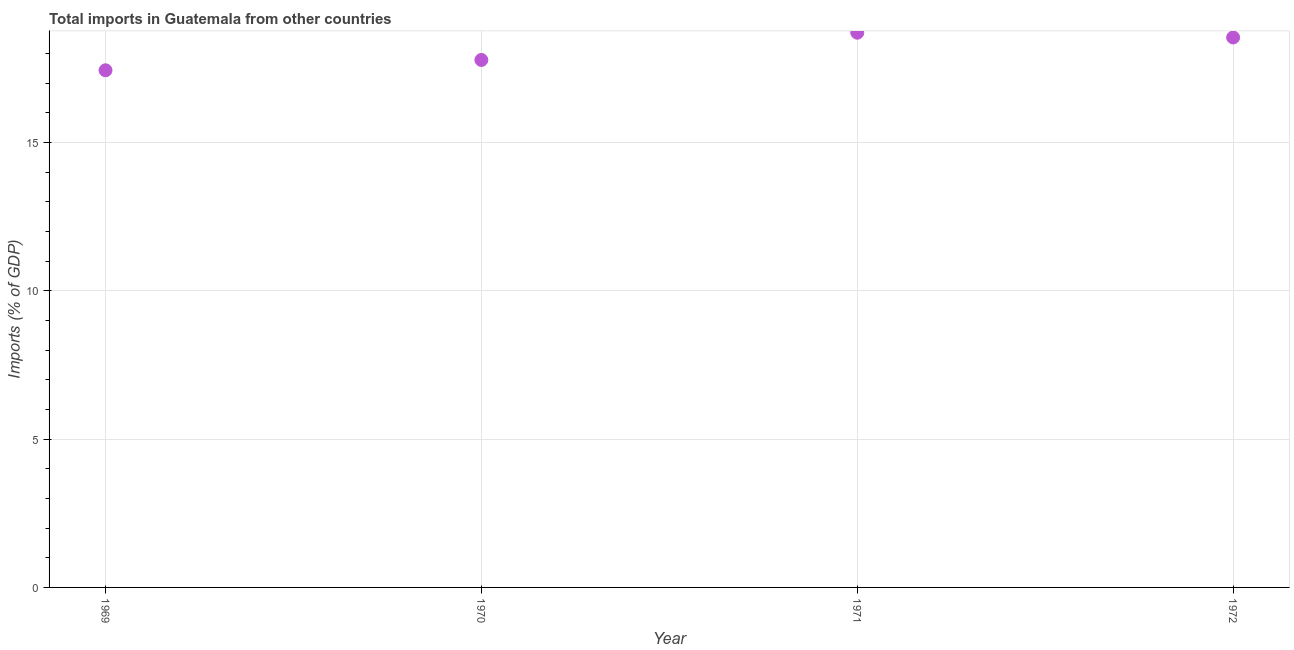What is the total imports in 1971?
Offer a terse response. 18.7. Across all years, what is the maximum total imports?
Provide a succinct answer. 18.7. Across all years, what is the minimum total imports?
Give a very brief answer. 17.43. In which year was the total imports minimum?
Provide a short and direct response. 1969. What is the sum of the total imports?
Your answer should be compact. 72.44. What is the difference between the total imports in 1969 and 1972?
Provide a short and direct response. -1.11. What is the average total imports per year?
Your answer should be compact. 18.11. What is the median total imports?
Ensure brevity in your answer.  18.16. In how many years, is the total imports greater than 13 %?
Your answer should be very brief. 4. Do a majority of the years between 1970 and 1971 (inclusive) have total imports greater than 9 %?
Your response must be concise. Yes. What is the ratio of the total imports in 1971 to that in 1972?
Make the answer very short. 1.01. Is the total imports in 1969 less than that in 1971?
Provide a succinct answer. Yes. Is the difference between the total imports in 1971 and 1972 greater than the difference between any two years?
Your response must be concise. No. What is the difference between the highest and the second highest total imports?
Your answer should be compact. 0.16. Is the sum of the total imports in 1969 and 1971 greater than the maximum total imports across all years?
Provide a short and direct response. Yes. What is the difference between the highest and the lowest total imports?
Your answer should be compact. 1.27. In how many years, is the total imports greater than the average total imports taken over all years?
Offer a terse response. 2. Does the total imports monotonically increase over the years?
Your answer should be compact. No. Does the graph contain any zero values?
Provide a short and direct response. No. Does the graph contain grids?
Your answer should be compact. Yes. What is the title of the graph?
Offer a terse response. Total imports in Guatemala from other countries. What is the label or title of the Y-axis?
Provide a short and direct response. Imports (% of GDP). What is the Imports (% of GDP) in 1969?
Provide a short and direct response. 17.43. What is the Imports (% of GDP) in 1970?
Make the answer very short. 17.78. What is the Imports (% of GDP) in 1971?
Provide a short and direct response. 18.7. What is the Imports (% of GDP) in 1972?
Ensure brevity in your answer.  18.54. What is the difference between the Imports (% of GDP) in 1969 and 1970?
Ensure brevity in your answer.  -0.35. What is the difference between the Imports (% of GDP) in 1969 and 1971?
Your answer should be very brief. -1.27. What is the difference between the Imports (% of GDP) in 1969 and 1972?
Keep it short and to the point. -1.11. What is the difference between the Imports (% of GDP) in 1970 and 1971?
Your answer should be very brief. -0.92. What is the difference between the Imports (% of GDP) in 1970 and 1972?
Make the answer very short. -0.76. What is the difference between the Imports (% of GDP) in 1971 and 1972?
Ensure brevity in your answer.  0.16. What is the ratio of the Imports (% of GDP) in 1969 to that in 1970?
Offer a very short reply. 0.98. What is the ratio of the Imports (% of GDP) in 1969 to that in 1971?
Offer a terse response. 0.93. What is the ratio of the Imports (% of GDP) in 1969 to that in 1972?
Make the answer very short. 0.94. What is the ratio of the Imports (% of GDP) in 1970 to that in 1971?
Offer a terse response. 0.95. What is the ratio of the Imports (% of GDP) in 1971 to that in 1972?
Ensure brevity in your answer.  1.01. 